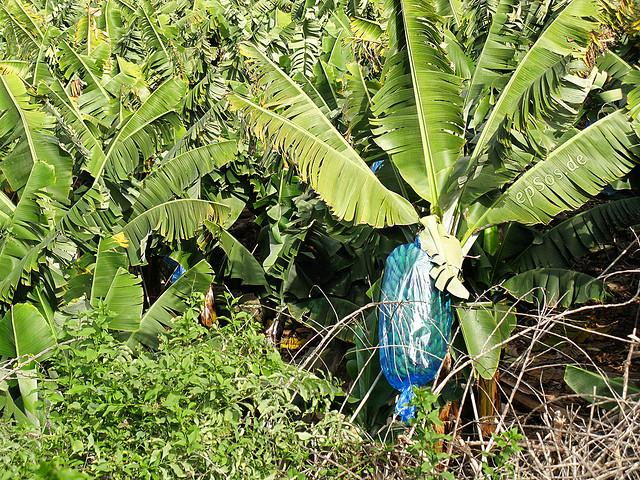What fruit is in the bright blue bag?

Choices:
A) kiwis
B) bananas
C) jackfruit
D) plantains bananas 